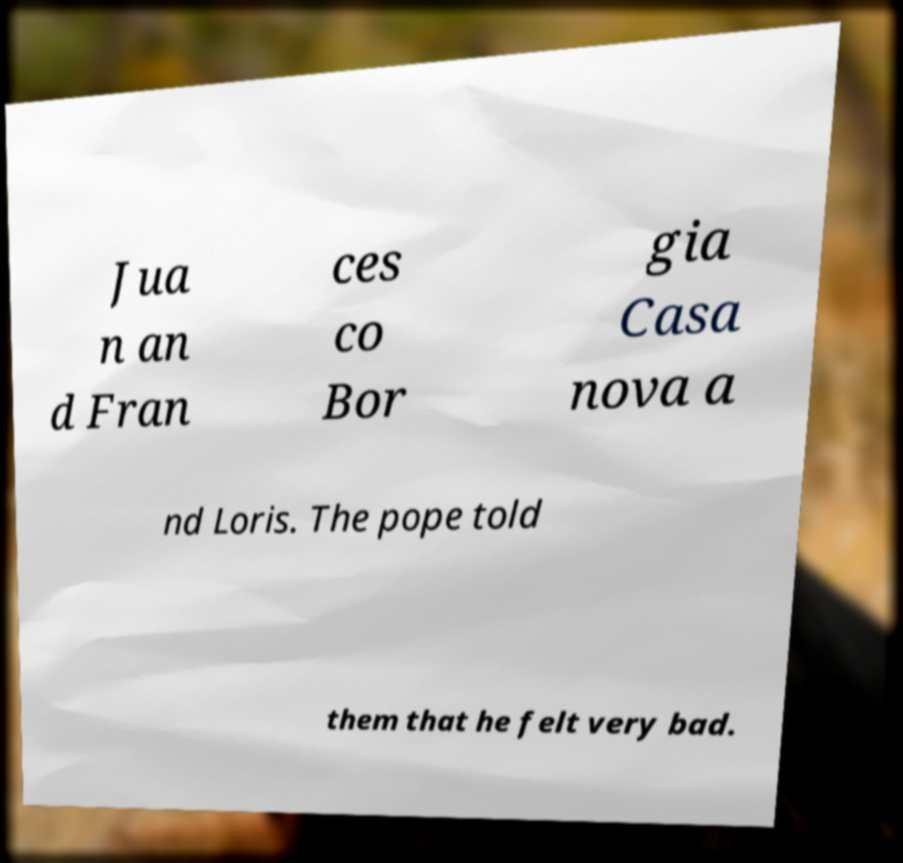Please identify and transcribe the text found in this image. Jua n an d Fran ces co Bor gia Casa nova a nd Loris. The pope told them that he felt very bad. 